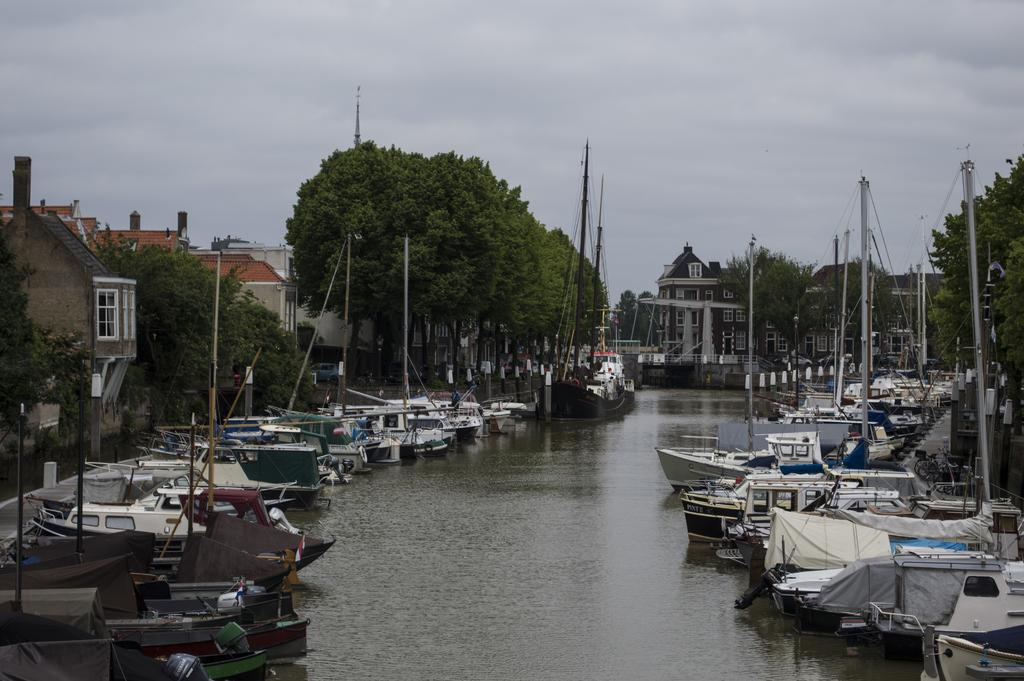What is present in large numbers in the water in the image? There are many boats in the water in the image. What structures can be seen in the image besides the boats? There are poles, trees, buildings, and water visible in the image. What is the condition of the sky in the image? The sky is cloudy in the image. Where are the tomatoes growing in the image? There are no tomatoes present in the image. How does the expansion of the buildings affect the boats in the image? There is no information about the expansion of the buildings or its effect on the boats in the image. 